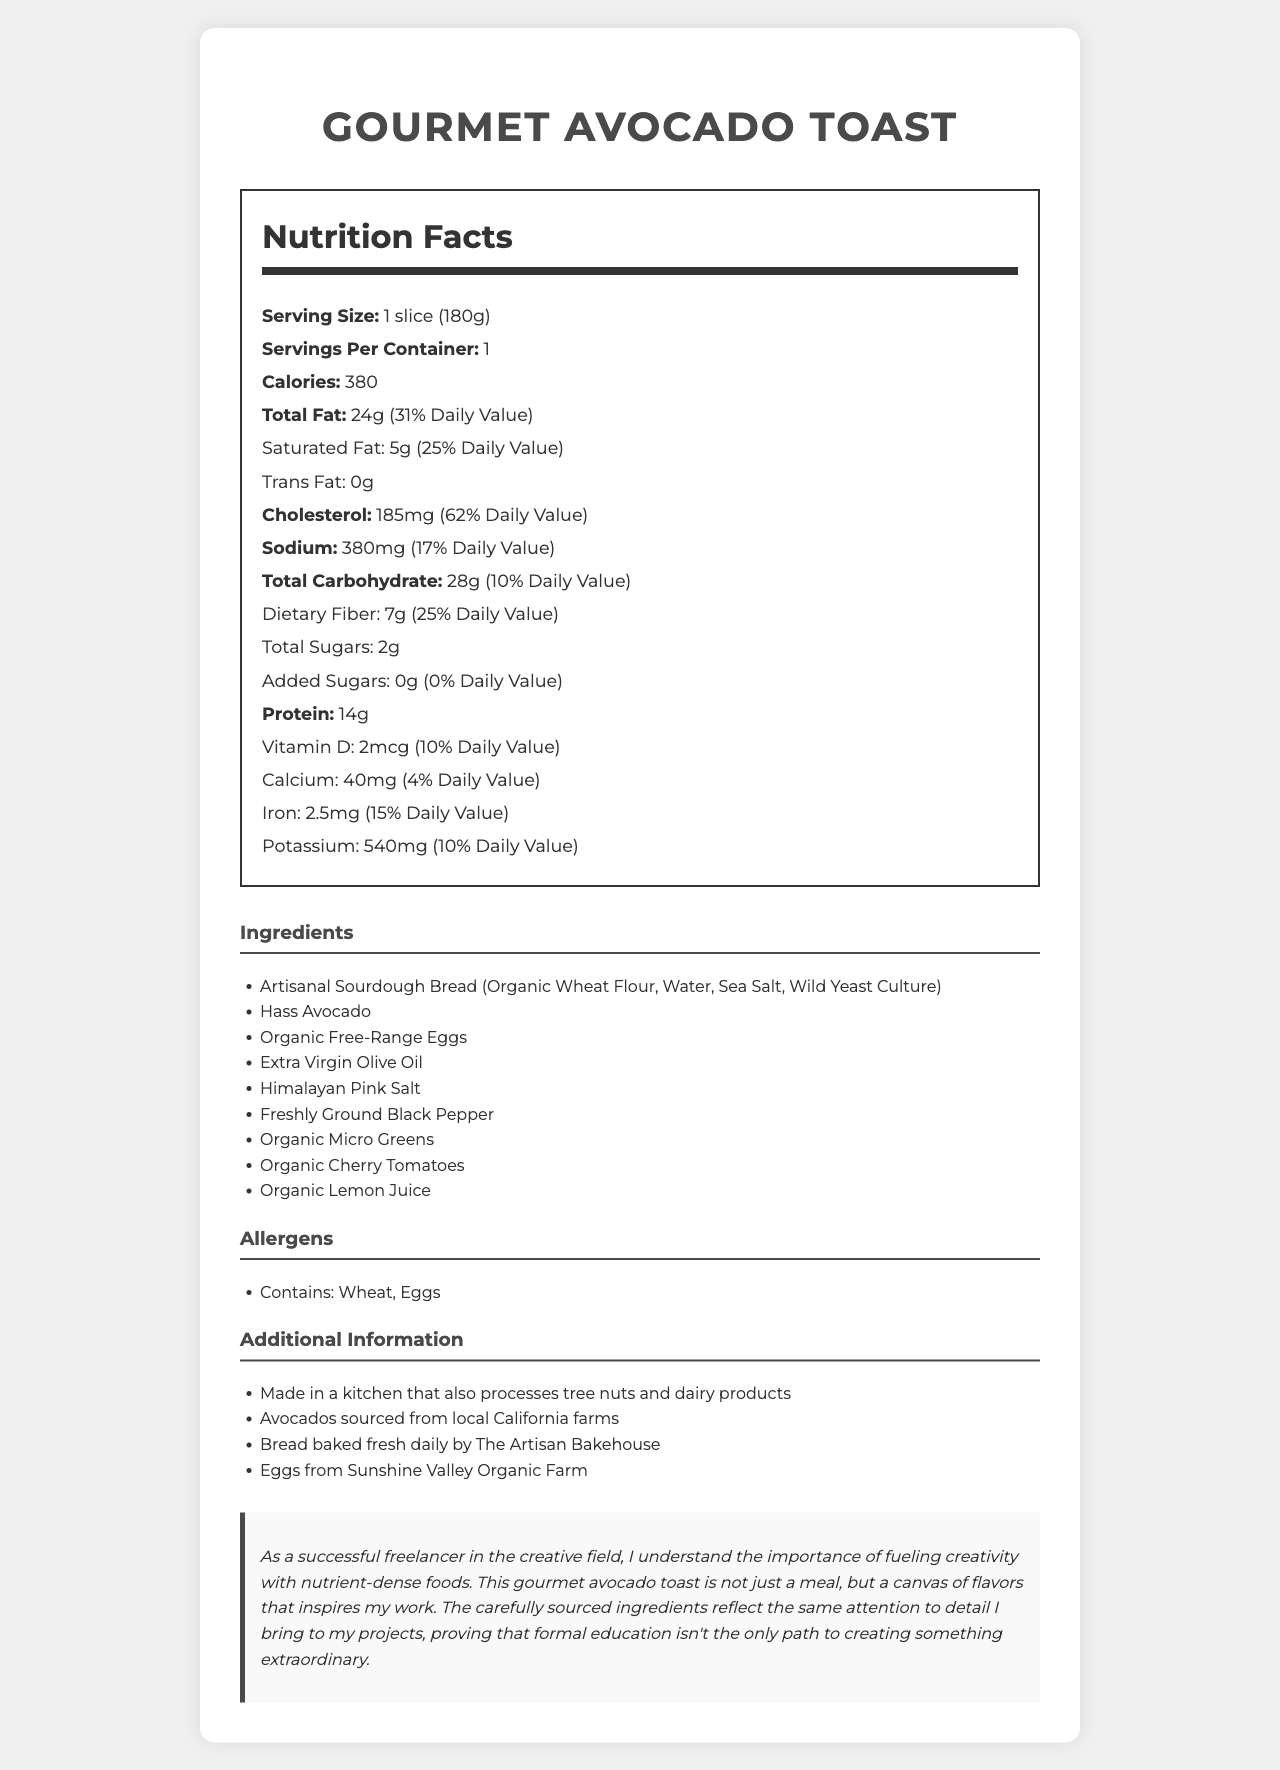what is the serving size? The serving size is listed at the top of the Nutrition Facts section. It states "Serving Size: 1 slice (180g)".
Answer: 1 slice (180g) how many calories are in a serving of the gourmet avocado toast? The document provides this information under the Nutrition Facts, where it states "Calories: 380".
Answer: 380 how much protein is in one serving, and what percentage of the daily value does this represent? The Nutrition Facts section states "Protein: 14g (28% Daily Value)".
Answer: 14g, 28% is there any trans fat in the avocado toast? Under the Nutrition Facts, it is written "Trans Fat: 0g".
Answer: No what allergens are present in this dish? The Allergens section lists "Contains: Wheat, Eggs".
Answer: Wheat and Eggs how much saturated fat is in the avocado toast? The Nutrition Facts section lists "Saturated Fat: 5g (25% Daily Value)".
Answer: 5g how many grams of dietary fiber are in a serving? The Dietary Fiber amount is mentioned in the Nutrition Facts section as "Dietary Fiber: 7g (25% Daily Value)".
Answer: 7g how many added sugars are in the avocado toast? The document states "Added Sugars: 0g (0% Daily Value)" under the Nutrition Facts.
Answer: 0g what is the amount of sodium in one serving? As per the Nutrition Facts section, it lists "Sodium: 380mg (17% Daily Value)".
Answer: 380mg what percentage of the daily value of cholesterol does one serving of avocado toast contain? A. 25% B. 31% C. 62% D. 10% The document states "Cholesterol: 185mg (62% Daily Value)" under the Nutrition Facts.
Answer: C. 62% which mineral is present in the greatest amount in one serving of the avocado toast? A. Calcium B. Iron C. Potassium D. Sodium The document lists the following minerals: Calcium (40mg), Iron (2.5mg), and Potassium (540mg). Potassium is present in the greatest amount.
Answer: C. Potassium is the avocado toast made in a kitchen that processes tree nuts and dairy products? The Additional Information section states that it is "Made in a kitchen that also processes tree nuts and dairy products".
Answer: Yes summarize the main idea of the document. The document includes various sections such as Nutrition Facts, Ingredients, Allergens, Additional Information, and a Creative Insight. Each section provides specific information about the nutritional content, the elements making up the dish, possible allergens, additional sourcing and processing details, and a personal note tying the attention to detail in food preparation to creative work.
Answer: The document provides detailed nutritional information, ingredients, and additional details about a gourmet avocado toast made with artisanal bread and organic eggs. It highlights its nutrient-dense composition, allergen information, and points out the use of high-quality, locally sourced ingredients. what is the source of the bread used in the avocado toast? The Additional Information section states, "Bread baked fresh daily by The Artisan Bakehouse."
Answer: The Artisan Bakehouse can you determine the exact amount of calories from fat for this dish based on the document? The document lists the total fat content but does not directly specify the calories derived from fat.
Answer: Cannot be determined where are the avocados sourced from? The Additional Information section mentions, "Avocados sourced from local California farms."
Answer: Local California farms who provides the eggs used in the avocado toast? The Additional Information section states, "Eggs from Sunshine Valley Organic Farm."
Answer: Sunshine Valley Organic Farm 